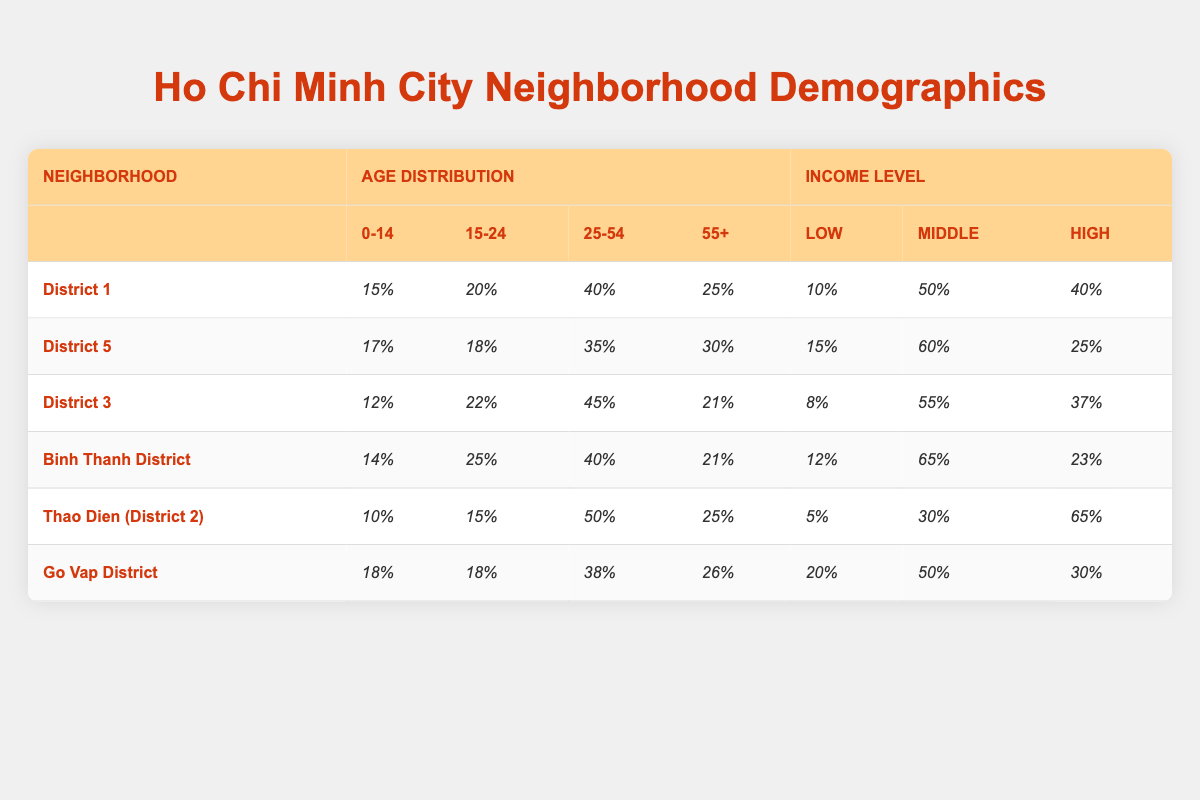What percentage of residents in District 1 are aged 0-14? According to the table, the age distribution in District 1 shows that 15% of residents are aged 0-14.
Answer: 15% Which neighborhood has the highest percentage of residents in the age group of 25-54? The table indicates that Thao Dien (District 2) has the highest percentage of residents aged 25-54 at 50%.
Answer: Thao Dien (District 2) What is the total percentage of low-income residents in District 5 and District 3 combined? For District 5, the percentage of low-income residents is 15%, and for District 3, it is 8%. Adding these gives 15% + 8% = 23%.
Answer: 23% Is it true that Binh Thanh District has more low-income residents than middle-income residents? The table shows that Binh Thanh District has 12% low-income residents and 65% middle-income residents. Therefore, the statement is false.
Answer: No Which neighborhood has the lowest percentage of high-income residents? The data indicates that District 5 has the lowest percentage of high-income residents at 25%.
Answer: District 5 What is the average percentage of low-income residents across all neighborhoods? To find the average, sum the low-income percentages: (10% + 15% + 8% + 12% + 5% + 20%) = 70%. There are 6 neighborhoods, so the average is 70% / 6 = 11.67%.
Answer: 11.67% What percentage of residents in Go Vap District fall within the age group of 15-24? According to the table, 18% of residents in Go Vap District are aged 15-24.
Answer: 18% Which district has the highest percentage of residents aged 55 and above? The table shows that District 5 has the highest percentage of residents aged 55 and above at 30%.
Answer: District 5 How many percent more middle-income residents are there in Binh Thanh District than in District 3? Binh Thanh District has 65% middle-income residents and District 3 has 55%. The difference is 65% - 55% = 10%.
Answer: 10% In which neighborhood do the majority of residents fall into the age group of 25-54? The highest percentage for the age group 25-54 is found in District 3 at 45%.
Answer: District 3 